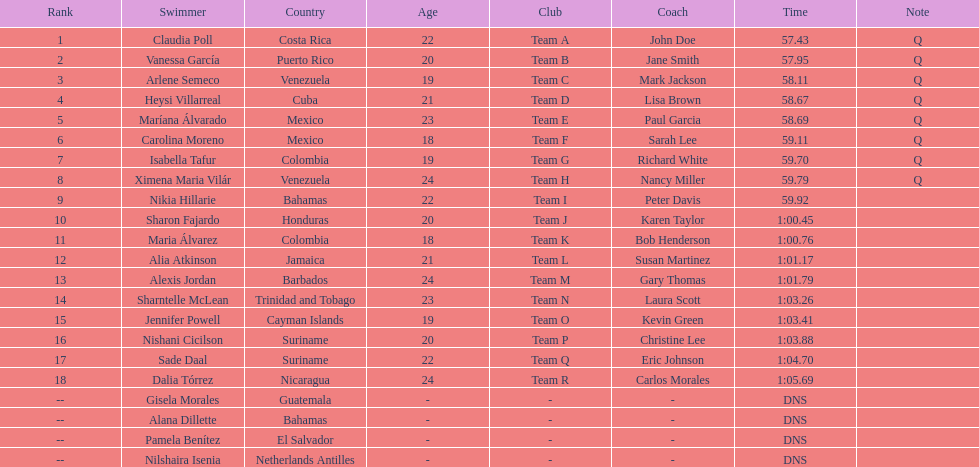Could you parse the entire table? {'header': ['Rank', 'Swimmer', 'Country', 'Age', 'Club', 'Coach', 'Time', 'Note'], 'rows': [['1', 'Claudia Poll', 'Costa Rica', '22', 'Team A', 'John Doe', '57.43', 'Q'], ['2', 'Vanessa García', 'Puerto Rico', '20', 'Team B', 'Jane Smith', '57.95', 'Q'], ['3', 'Arlene Semeco', 'Venezuela', '19', 'Team C', 'Mark Jackson', '58.11', 'Q'], ['4', 'Heysi Villarreal', 'Cuba', '21', 'Team D', 'Lisa Brown', '58.67', 'Q'], ['5', 'Maríana Álvarado', 'Mexico', '23', 'Team E', 'Paul Garcia', '58.69', 'Q'], ['6', 'Carolina Moreno', 'Mexico', '18', 'Team F', 'Sarah Lee', '59.11', 'Q'], ['7', 'Isabella Tafur', 'Colombia', '19', 'Team G', 'Richard White', '59.70', 'Q'], ['8', 'Ximena Maria Vilár', 'Venezuela', '24', 'Team H', 'Nancy Miller', '59.79', 'Q'], ['9', 'Nikia Hillarie', 'Bahamas', '22', 'Team I', 'Peter Davis', '59.92', ''], ['10', 'Sharon Fajardo', 'Honduras', '20', 'Team J', 'Karen Taylor', '1:00.45', ''], ['11', 'Maria Álvarez', 'Colombia', '18', 'Team K', 'Bob Henderson', '1:00.76', ''], ['12', 'Alia Atkinson', 'Jamaica', '21', 'Team L', 'Susan Martinez', '1:01.17', ''], ['13', 'Alexis Jordan', 'Barbados', '24', 'Team M', 'Gary Thomas', '1:01.79', ''], ['14', 'Sharntelle McLean', 'Trinidad and Tobago', '23', 'Team N', 'Laura Scott', '1:03.26', ''], ['15', 'Jennifer Powell', 'Cayman Islands', '19', 'Team O', 'Kevin Green', '1:03.41', ''], ['16', 'Nishani Cicilson', 'Suriname', '20', 'Team P', 'Christine Lee', '1:03.88', ''], ['17', 'Sade Daal', 'Suriname', '22', 'Team Q', 'Eric Johnson', '1:04.70', ''], ['18', 'Dalia Tórrez', 'Nicaragua', '24', 'Team R', 'Carlos Morales', '1:05.69', ''], ['--', 'Gisela Morales', 'Guatemala', '-', '-', '-', 'DNS', ''], ['--', 'Alana Dillette', 'Bahamas', '-', '-', '-', 'DNS', ''], ['--', 'Pamela Benítez', 'El Salvador', '-', '-', '-', 'DNS', ''], ['--', 'Nilshaira Isenia', 'Netherlands Antilles', '-', '-', '-', 'DNS', '']]} How many mexican swimmers ranked in the top 10? 2. 